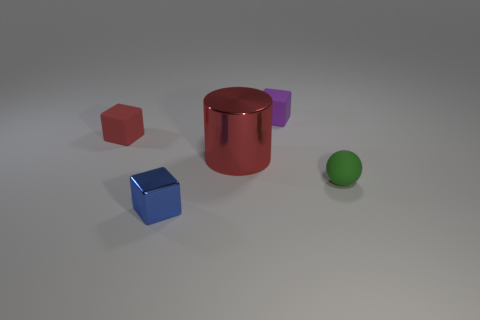Subtract all rubber blocks. How many blocks are left? 1 Add 1 big red cylinders. How many objects exist? 6 Subtract all blue blocks. How many blocks are left? 2 Subtract 2 blocks. How many blocks are left? 1 Subtract all blocks. How many objects are left? 2 Subtract all green cylinders. How many purple blocks are left? 1 Subtract all purple matte objects. Subtract all large blue objects. How many objects are left? 4 Add 4 tiny objects. How many tiny objects are left? 8 Add 5 tiny purple matte objects. How many tiny purple matte objects exist? 6 Subtract 0 purple cylinders. How many objects are left? 5 